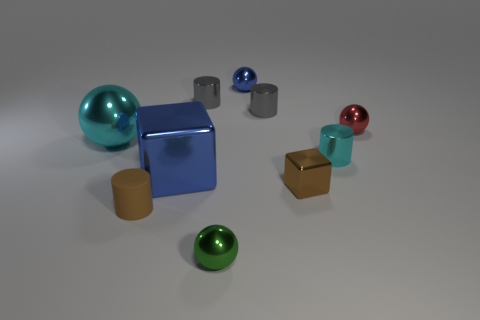Are there any other things that have the same material as the tiny brown cylinder?
Your response must be concise. No. What is the shape of the tiny blue shiny thing?
Keep it short and to the point. Sphere. There is a metal cube that is the same color as the matte cylinder; what size is it?
Your answer should be compact. Small. Do the blue thing in front of the cyan metallic cylinder and the cyan sphere have the same material?
Keep it short and to the point. Yes. Are there any big spheres that have the same color as the tiny rubber cylinder?
Provide a short and direct response. No. Is the shape of the blue thing that is behind the small cyan thing the same as the cyan object that is to the left of the tiny shiny cube?
Ensure brevity in your answer.  Yes. Are there any cyan cylinders made of the same material as the tiny green thing?
Offer a terse response. Yes. What number of gray objects are either matte balls or metallic things?
Give a very brief answer. 2. What is the size of the cylinder that is both behind the brown matte object and in front of the big cyan shiny ball?
Your answer should be very brief. Small. Is the number of red balls that are on the left side of the large blue metallic block greater than the number of tiny yellow objects?
Your answer should be very brief. No. 